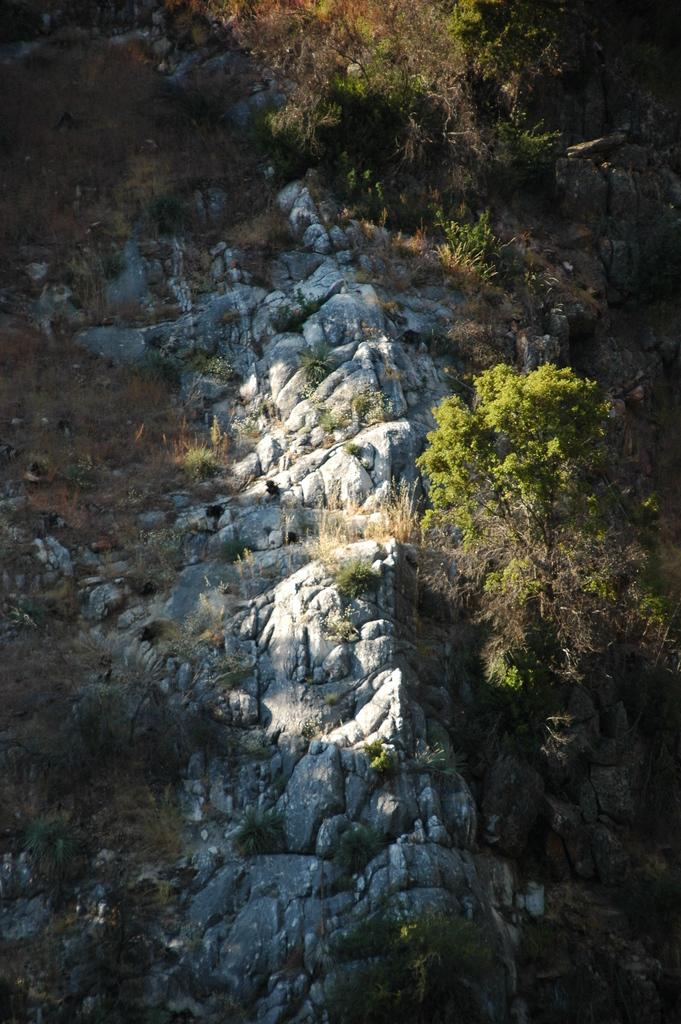What type of natural elements can be seen in the image? There are rocks in the image. What can be seen in the background of the image? There are trees visible in the background of the image. Is there an umbrella being used to protect against the battle in the image? There is no umbrella or battle present in the image; it features rocks and trees. What type of error can be seen in the image? There is no error present in the image; it features rocks and trees. 